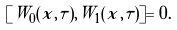Convert formula to latex. <formula><loc_0><loc_0><loc_500><loc_500>[ W _ { 0 } ( x , \tau ) , W _ { 1 } ( x , \tau ) ] = 0 .</formula> 